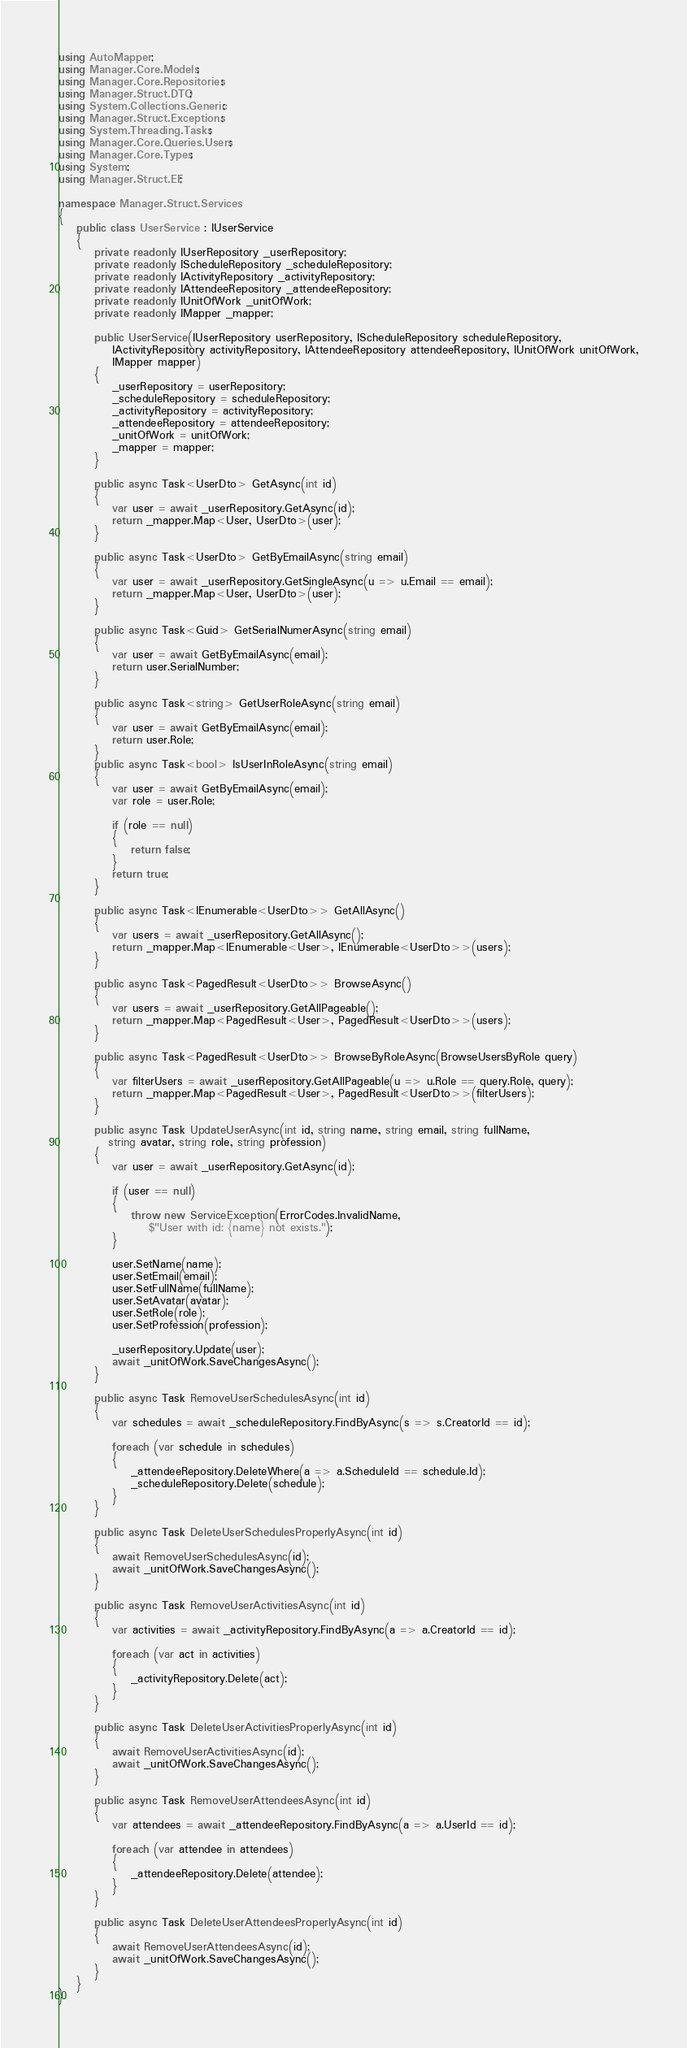Convert code to text. <code><loc_0><loc_0><loc_500><loc_500><_C#_>using AutoMapper;
using Manager.Core.Models;
using Manager.Core.Repositories;
using Manager.Struct.DTO;
using System.Collections.Generic;
using Manager.Struct.Exceptions;
using System.Threading.Tasks;
using Manager.Core.Queries.Users;
using Manager.Core.Types;
using System;
using Manager.Struct.EF;

namespace Manager.Struct.Services
{
    public class UserService : IUserService
    {
        private readonly IUserRepository _userRepository;
        private readonly IScheduleRepository _scheduleRepository;
        private readonly IActivityRepository _activityRepository;
        private readonly IAttendeeRepository _attendeeRepository;
        private readonly IUnitOfWork _unitOfWork;
        private readonly IMapper _mapper;

        public UserService(IUserRepository userRepository, IScheduleRepository scheduleRepository,
            IActivityRepository activityRepository, IAttendeeRepository attendeeRepository, IUnitOfWork unitOfWork,
            IMapper mapper)
        {
            _userRepository = userRepository;
            _scheduleRepository = scheduleRepository;
            _activityRepository = activityRepository;
            _attendeeRepository = attendeeRepository;
            _unitOfWork = unitOfWork;
            _mapper = mapper;
        }

        public async Task<UserDto> GetAsync(int id)
        {
            var user = await _userRepository.GetAsync(id);
            return _mapper.Map<User, UserDto>(user);
        }

        public async Task<UserDto> GetByEmailAsync(string email)
        {
            var user = await _userRepository.GetSingleAsync(u => u.Email == email);
            return _mapper.Map<User, UserDto>(user);
        }

        public async Task<Guid> GetSerialNumerAsync(string email)
        {
            var user = await GetByEmailAsync(email);
            return user.SerialNumber;
        }

        public async Task<string> GetUserRoleAsync(string email)
        {
            var user = await GetByEmailAsync(email);
            return user.Role;
        }
        public async Task<bool> IsUserInRoleAsync(string email)
        {
            var user = await GetByEmailAsync(email);
            var role = user.Role;

            if (role == null)
            {
                return false;
            }
            return true;
        }

        public async Task<IEnumerable<UserDto>> GetAllAsync()
        {
            var users = await _userRepository.GetAllAsync();
            return _mapper.Map<IEnumerable<User>, IEnumerable<UserDto>>(users);
        }

        public async Task<PagedResult<UserDto>> BrowseAsync()
        {
            var users = await _userRepository.GetAllPageable();
            return _mapper.Map<PagedResult<User>, PagedResult<UserDto>>(users);
        }

        public async Task<PagedResult<UserDto>> BrowseByRoleAsync(BrowseUsersByRole query)
        {
            var filterUsers = await _userRepository.GetAllPageable(u => u.Role == query.Role, query);
            return _mapper.Map<PagedResult<User>, PagedResult<UserDto>>(filterUsers);
        }

        public async Task UpdateUserAsync(int id, string name, string email, string fullName,
           string avatar, string role, string profession)
        {
            var user = await _userRepository.GetAsync(id);

            if (user == null)
            {
                throw new ServiceException(ErrorCodes.InvalidName,
                    $"User with id: {name} not exists.");
            }

            user.SetName(name);
            user.SetEmail(email);
            user.SetFullName(fullName);
            user.SetAvatar(avatar);
            user.SetRole(role);
            user.SetProfession(profession);

            _userRepository.Update(user);
            await _unitOfWork.SaveChangesAsync();
        }

        public async Task RemoveUserSchedulesAsync(int id)
        {
            var schedules = await _scheduleRepository.FindByAsync(s => s.CreatorId == id);

            foreach (var schedule in schedules)
            {
                _attendeeRepository.DeleteWhere(a => a.ScheduleId == schedule.Id);
                _scheduleRepository.Delete(schedule);
            }
        }

        public async Task DeleteUserSchedulesProperlyAsync(int id)
        {
            await RemoveUserSchedulesAsync(id);
            await _unitOfWork.SaveChangesAsync();
        }

        public async Task RemoveUserActivitiesAsync(int id)
        {
            var activities = await _activityRepository.FindByAsync(a => a.CreatorId == id);

            foreach (var act in activities)
            {
                _activityRepository.Delete(act);
            }
        }

        public async Task DeleteUserActivitiesProperlyAsync(int id)
        {
            await RemoveUserActivitiesAsync(id);
            await _unitOfWork.SaveChangesAsync();
        }

        public async Task RemoveUserAttendeesAsync(int id)
        {
            var attendees = await _attendeeRepository.FindByAsync(a => a.UserId == id);

            foreach (var attendee in attendees)
            {
                _attendeeRepository.Delete(attendee);
            }
        }

        public async Task DeleteUserAttendeesProperlyAsync(int id)
        {
            await RemoveUserAttendeesAsync(id);
            await _unitOfWork.SaveChangesAsync();
        }
    }
}</code> 